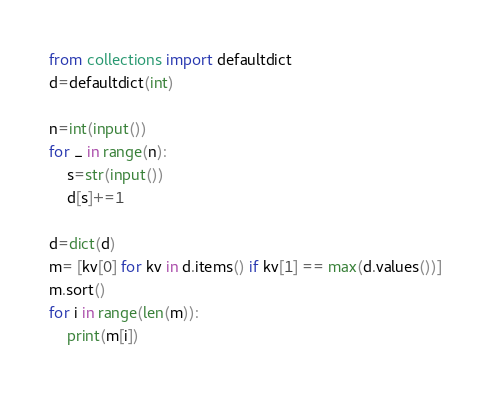Convert code to text. <code><loc_0><loc_0><loc_500><loc_500><_Python_>from collections import defaultdict
d=defaultdict(int)

n=int(input())
for _ in range(n):
    s=str(input())
    d[s]+=1

d=dict(d)
m= [kv[0] for kv in d.items() if kv[1] == max(d.values())]
m.sort()
for i in range(len(m)):
    print(m[i])</code> 